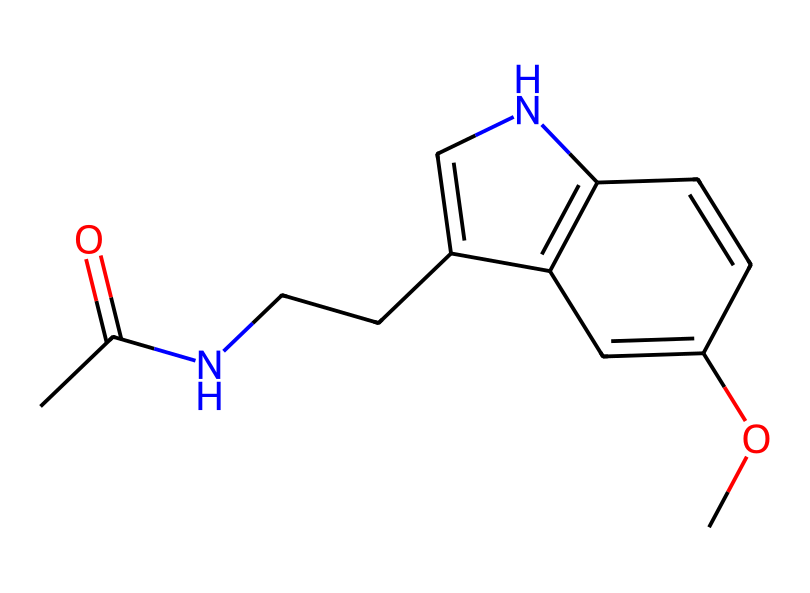What is the molecular formula of melatonin? To find the molecular formula from the SMILES representation, we can count the number of each type of atom present in the structure. Analyzing the SMILES string, we identify 13 carbon atoms, 16 hydrogen atoms, 2 nitrogen atoms, and 2 oxygen atoms. Thus, the molecular formula is C13H16N2O2.
Answer: C13H16N2O2 How many nitrogen atoms are present in melatonin? By examining the SMILES structure, we can clearly see two nitrogen atoms represented in the molecular formula. Counting directly, we find 2 nitrogen atoms in the chemical structure.
Answer: 2 What types of functional groups are present in melatonin? In the structural representation of melatonin, we can identify a carbonyl (C=O) group due to the acetate part and a methoxy (–OCH3) group due to the presence of an -OCH3 at one end of the benzene ring. Therefore, the functional groups present here are a carbonyl and a methoxy group.
Answer: carbonyl and methoxy Is melatonin a polar or non-polar molecule? The presence of polar functional groups (e.g., carbonyl and methoxy) suggests that the molecule has polar characteristics. However, the majority of the hydrocarbon structure can lead to a non-polar nature overall. A balance of these factors suggests that melatonin can be classified as a slightly polar molecule overall, but it leans more to the non-polar side due to its overall carbon framework.
Answer: slightly polar What type of molecule is melatonin categorized as? Melatonin is known as an indole derivative, due to the presence of the indole ring structure in its molecular framework. Further, since it does not dissociate into ions in solution, it is classified as a non-electrolyte. Therefore, the chemical can be categorized primarily as an indole derivative non-electrolyte.
Answer: indole derivative non-electrolyte 